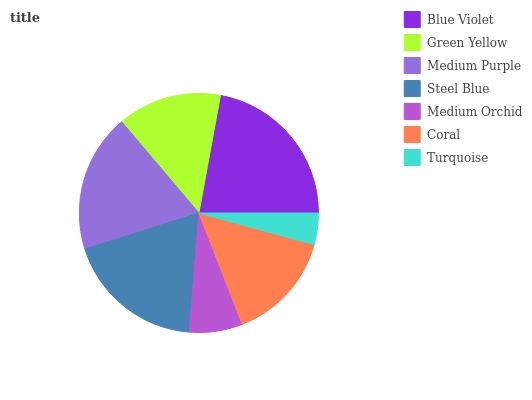Is Turquoise the minimum?
Answer yes or no. Yes. Is Blue Violet the maximum?
Answer yes or no. Yes. Is Green Yellow the minimum?
Answer yes or no. No. Is Green Yellow the maximum?
Answer yes or no. No. Is Blue Violet greater than Green Yellow?
Answer yes or no. Yes. Is Green Yellow less than Blue Violet?
Answer yes or no. Yes. Is Green Yellow greater than Blue Violet?
Answer yes or no. No. Is Blue Violet less than Green Yellow?
Answer yes or no. No. Is Coral the high median?
Answer yes or no. Yes. Is Coral the low median?
Answer yes or no. Yes. Is Steel Blue the high median?
Answer yes or no. No. Is Green Yellow the low median?
Answer yes or no. No. 